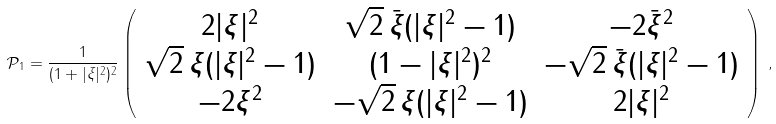<formula> <loc_0><loc_0><loc_500><loc_500>\mathcal { P } _ { 1 } = \frac { 1 } { ( 1 + | \xi | ^ { 2 } ) ^ { 2 } } \left ( \begin{array} { c c c } 2 | \xi | ^ { 2 } & \sqrt { 2 } \, \bar { \xi } ( | \xi | ^ { 2 } - 1 ) & - 2 \bar { \xi } ^ { 2 } \\ \sqrt { 2 } \, { \xi } ( | \xi | ^ { 2 } - 1 ) & ( 1 - | \xi | ^ { 2 } ) ^ { 2 } & - \sqrt { 2 } \, \bar { \xi } ( | \xi | ^ { 2 } - 1 ) \\ - 2 { \xi } ^ { 2 } & - \sqrt { 2 } \, { \xi } ( | \xi | ^ { 2 } - 1 ) & 2 | \xi | ^ { 2 } \end{array} \right ) \, ,</formula> 